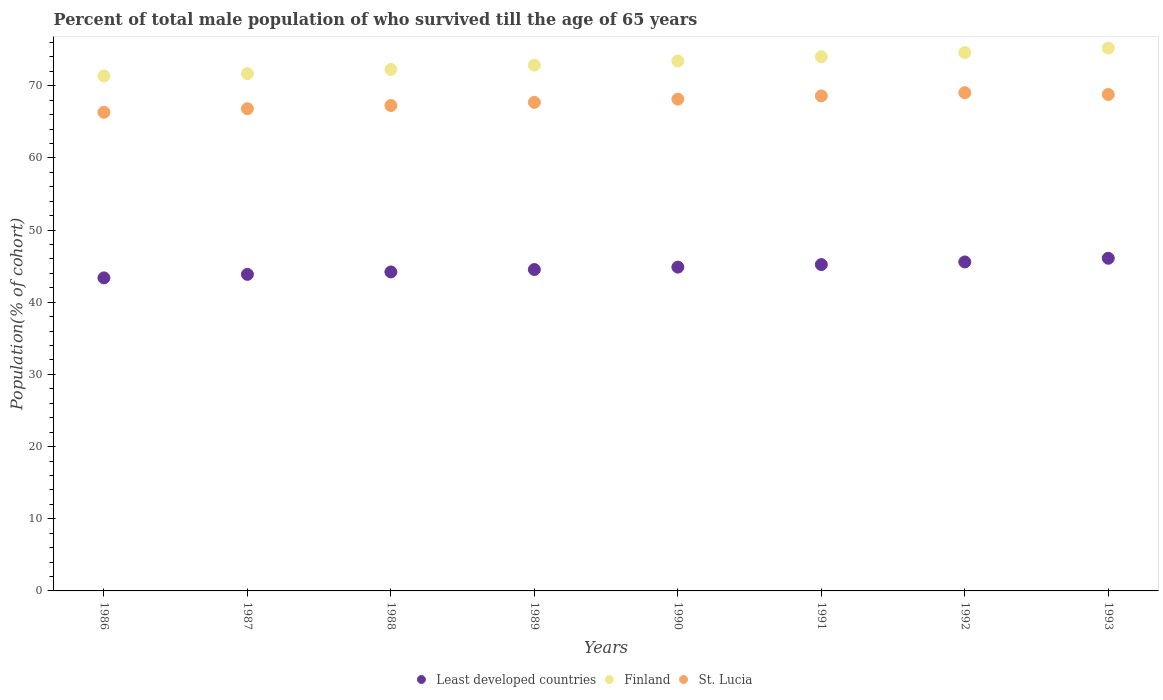What is the percentage of total male population who survived till the age of 65 years in Least developed countries in 1992?
Offer a very short reply. 45.58. Across all years, what is the maximum percentage of total male population who survived till the age of 65 years in Finland?
Your response must be concise. 75.22. Across all years, what is the minimum percentage of total male population who survived till the age of 65 years in Least developed countries?
Keep it short and to the point. 43.37. In which year was the percentage of total male population who survived till the age of 65 years in Finland minimum?
Your response must be concise. 1986. What is the total percentage of total male population who survived till the age of 65 years in Finland in the graph?
Provide a short and direct response. 585.42. What is the difference between the percentage of total male population who survived till the age of 65 years in Least developed countries in 1986 and that in 1993?
Ensure brevity in your answer.  -2.72. What is the difference between the percentage of total male population who survived till the age of 65 years in Least developed countries in 1988 and the percentage of total male population who survived till the age of 65 years in Finland in 1990?
Make the answer very short. -29.23. What is the average percentage of total male population who survived till the age of 65 years in Least developed countries per year?
Offer a very short reply. 44.72. In the year 1987, what is the difference between the percentage of total male population who survived till the age of 65 years in St. Lucia and percentage of total male population who survived till the age of 65 years in Least developed countries?
Provide a succinct answer. 22.95. In how many years, is the percentage of total male population who survived till the age of 65 years in Finland greater than 22 %?
Your response must be concise. 8. What is the ratio of the percentage of total male population who survived till the age of 65 years in St. Lucia in 1986 to that in 1989?
Your response must be concise. 0.98. Is the difference between the percentage of total male population who survived till the age of 65 years in St. Lucia in 1990 and 1993 greater than the difference between the percentage of total male population who survived till the age of 65 years in Least developed countries in 1990 and 1993?
Your answer should be very brief. Yes. What is the difference between the highest and the second highest percentage of total male population who survived till the age of 65 years in Least developed countries?
Offer a very short reply. 0.51. What is the difference between the highest and the lowest percentage of total male population who survived till the age of 65 years in St. Lucia?
Offer a terse response. 2.71. Does the percentage of total male population who survived till the age of 65 years in Finland monotonically increase over the years?
Provide a succinct answer. Yes. Is the percentage of total male population who survived till the age of 65 years in Least developed countries strictly greater than the percentage of total male population who survived till the age of 65 years in St. Lucia over the years?
Keep it short and to the point. No. Is the percentage of total male population who survived till the age of 65 years in Finland strictly less than the percentage of total male population who survived till the age of 65 years in Least developed countries over the years?
Provide a short and direct response. No. How many dotlines are there?
Provide a succinct answer. 3. Does the graph contain grids?
Make the answer very short. No. What is the title of the graph?
Offer a terse response. Percent of total male population of who survived till the age of 65 years. Does "Venezuela" appear as one of the legend labels in the graph?
Give a very brief answer. No. What is the label or title of the Y-axis?
Your response must be concise. Population(% of cohort). What is the Population(% of cohort) of Least developed countries in 1986?
Your response must be concise. 43.37. What is the Population(% of cohort) in Finland in 1986?
Your answer should be very brief. 71.36. What is the Population(% of cohort) in St. Lucia in 1986?
Ensure brevity in your answer.  66.32. What is the Population(% of cohort) in Least developed countries in 1987?
Make the answer very short. 43.86. What is the Population(% of cohort) of Finland in 1987?
Give a very brief answer. 71.68. What is the Population(% of cohort) in St. Lucia in 1987?
Offer a terse response. 66.81. What is the Population(% of cohort) in Least developed countries in 1988?
Provide a short and direct response. 44.2. What is the Population(% of cohort) in Finland in 1988?
Your answer should be compact. 72.26. What is the Population(% of cohort) of St. Lucia in 1988?
Ensure brevity in your answer.  67.26. What is the Population(% of cohort) of Least developed countries in 1989?
Offer a very short reply. 44.53. What is the Population(% of cohort) of Finland in 1989?
Ensure brevity in your answer.  72.85. What is the Population(% of cohort) in St. Lucia in 1989?
Ensure brevity in your answer.  67.7. What is the Population(% of cohort) in Least developed countries in 1990?
Ensure brevity in your answer.  44.87. What is the Population(% of cohort) of Finland in 1990?
Provide a short and direct response. 73.43. What is the Population(% of cohort) of St. Lucia in 1990?
Provide a short and direct response. 68.14. What is the Population(% of cohort) of Least developed countries in 1991?
Offer a very short reply. 45.22. What is the Population(% of cohort) in Finland in 1991?
Offer a very short reply. 74.02. What is the Population(% of cohort) in St. Lucia in 1991?
Your answer should be very brief. 68.59. What is the Population(% of cohort) of Least developed countries in 1992?
Keep it short and to the point. 45.58. What is the Population(% of cohort) in Finland in 1992?
Offer a very short reply. 74.61. What is the Population(% of cohort) in St. Lucia in 1992?
Give a very brief answer. 69.03. What is the Population(% of cohort) in Least developed countries in 1993?
Your answer should be very brief. 46.09. What is the Population(% of cohort) in Finland in 1993?
Ensure brevity in your answer.  75.22. What is the Population(% of cohort) of St. Lucia in 1993?
Provide a succinct answer. 68.79. Across all years, what is the maximum Population(% of cohort) of Least developed countries?
Give a very brief answer. 46.09. Across all years, what is the maximum Population(% of cohort) of Finland?
Give a very brief answer. 75.22. Across all years, what is the maximum Population(% of cohort) of St. Lucia?
Your answer should be compact. 69.03. Across all years, what is the minimum Population(% of cohort) of Least developed countries?
Your response must be concise. 43.37. Across all years, what is the minimum Population(% of cohort) in Finland?
Give a very brief answer. 71.36. Across all years, what is the minimum Population(% of cohort) in St. Lucia?
Ensure brevity in your answer.  66.32. What is the total Population(% of cohort) in Least developed countries in the graph?
Make the answer very short. 357.73. What is the total Population(% of cohort) of Finland in the graph?
Provide a succinct answer. 585.42. What is the total Population(% of cohort) of St. Lucia in the graph?
Make the answer very short. 542.64. What is the difference between the Population(% of cohort) in Least developed countries in 1986 and that in 1987?
Give a very brief answer. -0.49. What is the difference between the Population(% of cohort) of Finland in 1986 and that in 1987?
Ensure brevity in your answer.  -0.32. What is the difference between the Population(% of cohort) in St. Lucia in 1986 and that in 1987?
Give a very brief answer. -0.49. What is the difference between the Population(% of cohort) of Least developed countries in 1986 and that in 1988?
Your response must be concise. -0.83. What is the difference between the Population(% of cohort) of Finland in 1986 and that in 1988?
Your answer should be compact. -0.9. What is the difference between the Population(% of cohort) of St. Lucia in 1986 and that in 1988?
Ensure brevity in your answer.  -0.93. What is the difference between the Population(% of cohort) of Least developed countries in 1986 and that in 1989?
Ensure brevity in your answer.  -1.16. What is the difference between the Population(% of cohort) of Finland in 1986 and that in 1989?
Offer a terse response. -1.49. What is the difference between the Population(% of cohort) in St. Lucia in 1986 and that in 1989?
Make the answer very short. -1.38. What is the difference between the Population(% of cohort) of Least developed countries in 1986 and that in 1990?
Ensure brevity in your answer.  -1.49. What is the difference between the Population(% of cohort) of Finland in 1986 and that in 1990?
Give a very brief answer. -2.08. What is the difference between the Population(% of cohort) of St. Lucia in 1986 and that in 1990?
Keep it short and to the point. -1.82. What is the difference between the Population(% of cohort) in Least developed countries in 1986 and that in 1991?
Offer a terse response. -1.84. What is the difference between the Population(% of cohort) in Finland in 1986 and that in 1991?
Make the answer very short. -2.66. What is the difference between the Population(% of cohort) in St. Lucia in 1986 and that in 1991?
Provide a short and direct response. -2.27. What is the difference between the Population(% of cohort) in Least developed countries in 1986 and that in 1992?
Make the answer very short. -2.21. What is the difference between the Population(% of cohort) in Finland in 1986 and that in 1992?
Make the answer very short. -3.25. What is the difference between the Population(% of cohort) in St. Lucia in 1986 and that in 1992?
Keep it short and to the point. -2.71. What is the difference between the Population(% of cohort) in Least developed countries in 1986 and that in 1993?
Your response must be concise. -2.72. What is the difference between the Population(% of cohort) of Finland in 1986 and that in 1993?
Provide a short and direct response. -3.86. What is the difference between the Population(% of cohort) of St. Lucia in 1986 and that in 1993?
Ensure brevity in your answer.  -2.46. What is the difference between the Population(% of cohort) in Least developed countries in 1987 and that in 1988?
Your answer should be very brief. -0.34. What is the difference between the Population(% of cohort) in Finland in 1987 and that in 1988?
Provide a short and direct response. -0.59. What is the difference between the Population(% of cohort) in St. Lucia in 1987 and that in 1988?
Provide a succinct answer. -0.44. What is the difference between the Population(% of cohort) of Least developed countries in 1987 and that in 1989?
Your response must be concise. -0.67. What is the difference between the Population(% of cohort) in Finland in 1987 and that in 1989?
Provide a short and direct response. -1.17. What is the difference between the Population(% of cohort) in St. Lucia in 1987 and that in 1989?
Offer a very short reply. -0.89. What is the difference between the Population(% of cohort) in Least developed countries in 1987 and that in 1990?
Offer a terse response. -1. What is the difference between the Population(% of cohort) in Finland in 1987 and that in 1990?
Your answer should be compact. -1.76. What is the difference between the Population(% of cohort) of St. Lucia in 1987 and that in 1990?
Ensure brevity in your answer.  -1.33. What is the difference between the Population(% of cohort) of Least developed countries in 1987 and that in 1991?
Your response must be concise. -1.36. What is the difference between the Population(% of cohort) in Finland in 1987 and that in 1991?
Your answer should be very brief. -2.34. What is the difference between the Population(% of cohort) in St. Lucia in 1987 and that in 1991?
Make the answer very short. -1.78. What is the difference between the Population(% of cohort) of Least developed countries in 1987 and that in 1992?
Your answer should be very brief. -1.72. What is the difference between the Population(% of cohort) in Finland in 1987 and that in 1992?
Your answer should be very brief. -2.93. What is the difference between the Population(% of cohort) in St. Lucia in 1987 and that in 1992?
Ensure brevity in your answer.  -2.22. What is the difference between the Population(% of cohort) of Least developed countries in 1987 and that in 1993?
Your response must be concise. -2.23. What is the difference between the Population(% of cohort) of Finland in 1987 and that in 1993?
Make the answer very short. -3.54. What is the difference between the Population(% of cohort) in St. Lucia in 1987 and that in 1993?
Your answer should be compact. -1.97. What is the difference between the Population(% of cohort) of Least developed countries in 1988 and that in 1989?
Offer a terse response. -0.33. What is the difference between the Population(% of cohort) in Finland in 1988 and that in 1989?
Ensure brevity in your answer.  -0.59. What is the difference between the Population(% of cohort) in St. Lucia in 1988 and that in 1989?
Offer a very short reply. -0.44. What is the difference between the Population(% of cohort) of Least developed countries in 1988 and that in 1990?
Your answer should be very brief. -0.67. What is the difference between the Population(% of cohort) of Finland in 1988 and that in 1990?
Give a very brief answer. -1.17. What is the difference between the Population(% of cohort) of St. Lucia in 1988 and that in 1990?
Your answer should be compact. -0.89. What is the difference between the Population(% of cohort) of Least developed countries in 1988 and that in 1991?
Ensure brevity in your answer.  -1.02. What is the difference between the Population(% of cohort) in Finland in 1988 and that in 1991?
Give a very brief answer. -1.76. What is the difference between the Population(% of cohort) in St. Lucia in 1988 and that in 1991?
Make the answer very short. -1.33. What is the difference between the Population(% of cohort) of Least developed countries in 1988 and that in 1992?
Offer a very short reply. -1.38. What is the difference between the Population(% of cohort) of Finland in 1988 and that in 1992?
Your answer should be very brief. -2.34. What is the difference between the Population(% of cohort) in St. Lucia in 1988 and that in 1992?
Provide a succinct answer. -1.78. What is the difference between the Population(% of cohort) of Least developed countries in 1988 and that in 1993?
Ensure brevity in your answer.  -1.9. What is the difference between the Population(% of cohort) in Finland in 1988 and that in 1993?
Keep it short and to the point. -2.96. What is the difference between the Population(% of cohort) of St. Lucia in 1988 and that in 1993?
Ensure brevity in your answer.  -1.53. What is the difference between the Population(% of cohort) in Least developed countries in 1989 and that in 1990?
Your answer should be compact. -0.33. What is the difference between the Population(% of cohort) of Finland in 1989 and that in 1990?
Make the answer very short. -0.59. What is the difference between the Population(% of cohort) in St. Lucia in 1989 and that in 1990?
Make the answer very short. -0.44. What is the difference between the Population(% of cohort) of Least developed countries in 1989 and that in 1991?
Your answer should be compact. -0.69. What is the difference between the Population(% of cohort) of Finland in 1989 and that in 1991?
Your answer should be compact. -1.17. What is the difference between the Population(% of cohort) of St. Lucia in 1989 and that in 1991?
Give a very brief answer. -0.89. What is the difference between the Population(% of cohort) in Least developed countries in 1989 and that in 1992?
Offer a very short reply. -1.05. What is the difference between the Population(% of cohort) of Finland in 1989 and that in 1992?
Provide a succinct answer. -1.76. What is the difference between the Population(% of cohort) in St. Lucia in 1989 and that in 1992?
Give a very brief answer. -1.33. What is the difference between the Population(% of cohort) of Least developed countries in 1989 and that in 1993?
Your response must be concise. -1.56. What is the difference between the Population(% of cohort) of Finland in 1989 and that in 1993?
Offer a very short reply. -2.37. What is the difference between the Population(% of cohort) in St. Lucia in 1989 and that in 1993?
Your answer should be very brief. -1.09. What is the difference between the Population(% of cohort) of Least developed countries in 1990 and that in 1991?
Provide a short and direct response. -0.35. What is the difference between the Population(% of cohort) of Finland in 1990 and that in 1991?
Your answer should be compact. -0.59. What is the difference between the Population(% of cohort) of St. Lucia in 1990 and that in 1991?
Provide a succinct answer. -0.44. What is the difference between the Population(% of cohort) in Least developed countries in 1990 and that in 1992?
Offer a terse response. -0.72. What is the difference between the Population(% of cohort) of Finland in 1990 and that in 1992?
Offer a very short reply. -1.17. What is the difference between the Population(% of cohort) in St. Lucia in 1990 and that in 1992?
Make the answer very short. -0.89. What is the difference between the Population(% of cohort) in Least developed countries in 1990 and that in 1993?
Your answer should be compact. -1.23. What is the difference between the Population(% of cohort) of Finland in 1990 and that in 1993?
Your answer should be compact. -1.78. What is the difference between the Population(% of cohort) of St. Lucia in 1990 and that in 1993?
Offer a terse response. -0.64. What is the difference between the Population(% of cohort) in Least developed countries in 1991 and that in 1992?
Provide a succinct answer. -0.36. What is the difference between the Population(% of cohort) in Finland in 1991 and that in 1992?
Provide a succinct answer. -0.59. What is the difference between the Population(% of cohort) of St. Lucia in 1991 and that in 1992?
Give a very brief answer. -0.44. What is the difference between the Population(% of cohort) in Least developed countries in 1991 and that in 1993?
Your response must be concise. -0.88. What is the difference between the Population(% of cohort) in Finland in 1991 and that in 1993?
Keep it short and to the point. -1.2. What is the difference between the Population(% of cohort) of St. Lucia in 1991 and that in 1993?
Provide a short and direct response. -0.2. What is the difference between the Population(% of cohort) in Least developed countries in 1992 and that in 1993?
Ensure brevity in your answer.  -0.51. What is the difference between the Population(% of cohort) in Finland in 1992 and that in 1993?
Give a very brief answer. -0.61. What is the difference between the Population(% of cohort) in St. Lucia in 1992 and that in 1993?
Offer a terse response. 0.25. What is the difference between the Population(% of cohort) of Least developed countries in 1986 and the Population(% of cohort) of Finland in 1987?
Provide a short and direct response. -28.3. What is the difference between the Population(% of cohort) of Least developed countries in 1986 and the Population(% of cohort) of St. Lucia in 1987?
Your response must be concise. -23.44. What is the difference between the Population(% of cohort) in Finland in 1986 and the Population(% of cohort) in St. Lucia in 1987?
Make the answer very short. 4.55. What is the difference between the Population(% of cohort) of Least developed countries in 1986 and the Population(% of cohort) of Finland in 1988?
Keep it short and to the point. -28.89. What is the difference between the Population(% of cohort) of Least developed countries in 1986 and the Population(% of cohort) of St. Lucia in 1988?
Give a very brief answer. -23.88. What is the difference between the Population(% of cohort) of Finland in 1986 and the Population(% of cohort) of St. Lucia in 1988?
Your answer should be compact. 4.1. What is the difference between the Population(% of cohort) of Least developed countries in 1986 and the Population(% of cohort) of Finland in 1989?
Your answer should be very brief. -29.47. What is the difference between the Population(% of cohort) in Least developed countries in 1986 and the Population(% of cohort) in St. Lucia in 1989?
Provide a short and direct response. -24.33. What is the difference between the Population(% of cohort) of Finland in 1986 and the Population(% of cohort) of St. Lucia in 1989?
Your answer should be very brief. 3.66. What is the difference between the Population(% of cohort) in Least developed countries in 1986 and the Population(% of cohort) in Finland in 1990?
Provide a succinct answer. -30.06. What is the difference between the Population(% of cohort) of Least developed countries in 1986 and the Population(% of cohort) of St. Lucia in 1990?
Keep it short and to the point. -24.77. What is the difference between the Population(% of cohort) in Finland in 1986 and the Population(% of cohort) in St. Lucia in 1990?
Make the answer very short. 3.21. What is the difference between the Population(% of cohort) of Least developed countries in 1986 and the Population(% of cohort) of Finland in 1991?
Your answer should be compact. -30.65. What is the difference between the Population(% of cohort) in Least developed countries in 1986 and the Population(% of cohort) in St. Lucia in 1991?
Your answer should be very brief. -25.22. What is the difference between the Population(% of cohort) of Finland in 1986 and the Population(% of cohort) of St. Lucia in 1991?
Offer a terse response. 2.77. What is the difference between the Population(% of cohort) of Least developed countries in 1986 and the Population(% of cohort) of Finland in 1992?
Your answer should be very brief. -31.23. What is the difference between the Population(% of cohort) in Least developed countries in 1986 and the Population(% of cohort) in St. Lucia in 1992?
Make the answer very short. -25.66. What is the difference between the Population(% of cohort) in Finland in 1986 and the Population(% of cohort) in St. Lucia in 1992?
Provide a short and direct response. 2.32. What is the difference between the Population(% of cohort) in Least developed countries in 1986 and the Population(% of cohort) in Finland in 1993?
Keep it short and to the point. -31.84. What is the difference between the Population(% of cohort) of Least developed countries in 1986 and the Population(% of cohort) of St. Lucia in 1993?
Give a very brief answer. -25.41. What is the difference between the Population(% of cohort) of Finland in 1986 and the Population(% of cohort) of St. Lucia in 1993?
Make the answer very short. 2.57. What is the difference between the Population(% of cohort) in Least developed countries in 1987 and the Population(% of cohort) in Finland in 1988?
Give a very brief answer. -28.4. What is the difference between the Population(% of cohort) of Least developed countries in 1987 and the Population(% of cohort) of St. Lucia in 1988?
Provide a short and direct response. -23.39. What is the difference between the Population(% of cohort) in Finland in 1987 and the Population(% of cohort) in St. Lucia in 1988?
Your response must be concise. 4.42. What is the difference between the Population(% of cohort) in Least developed countries in 1987 and the Population(% of cohort) in Finland in 1989?
Ensure brevity in your answer.  -28.99. What is the difference between the Population(% of cohort) in Least developed countries in 1987 and the Population(% of cohort) in St. Lucia in 1989?
Make the answer very short. -23.84. What is the difference between the Population(% of cohort) in Finland in 1987 and the Population(% of cohort) in St. Lucia in 1989?
Make the answer very short. 3.98. What is the difference between the Population(% of cohort) of Least developed countries in 1987 and the Population(% of cohort) of Finland in 1990?
Offer a very short reply. -29.57. What is the difference between the Population(% of cohort) of Least developed countries in 1987 and the Population(% of cohort) of St. Lucia in 1990?
Offer a terse response. -24.28. What is the difference between the Population(% of cohort) of Finland in 1987 and the Population(% of cohort) of St. Lucia in 1990?
Provide a short and direct response. 3.53. What is the difference between the Population(% of cohort) of Least developed countries in 1987 and the Population(% of cohort) of Finland in 1991?
Make the answer very short. -30.16. What is the difference between the Population(% of cohort) of Least developed countries in 1987 and the Population(% of cohort) of St. Lucia in 1991?
Make the answer very short. -24.73. What is the difference between the Population(% of cohort) of Finland in 1987 and the Population(% of cohort) of St. Lucia in 1991?
Your answer should be very brief. 3.09. What is the difference between the Population(% of cohort) in Least developed countries in 1987 and the Population(% of cohort) in Finland in 1992?
Your response must be concise. -30.74. What is the difference between the Population(% of cohort) in Least developed countries in 1987 and the Population(% of cohort) in St. Lucia in 1992?
Offer a very short reply. -25.17. What is the difference between the Population(% of cohort) of Finland in 1987 and the Population(% of cohort) of St. Lucia in 1992?
Offer a terse response. 2.64. What is the difference between the Population(% of cohort) of Least developed countries in 1987 and the Population(% of cohort) of Finland in 1993?
Your response must be concise. -31.36. What is the difference between the Population(% of cohort) in Least developed countries in 1987 and the Population(% of cohort) in St. Lucia in 1993?
Ensure brevity in your answer.  -24.92. What is the difference between the Population(% of cohort) of Finland in 1987 and the Population(% of cohort) of St. Lucia in 1993?
Your answer should be very brief. 2.89. What is the difference between the Population(% of cohort) in Least developed countries in 1988 and the Population(% of cohort) in Finland in 1989?
Your answer should be compact. -28.65. What is the difference between the Population(% of cohort) in Least developed countries in 1988 and the Population(% of cohort) in St. Lucia in 1989?
Provide a short and direct response. -23.5. What is the difference between the Population(% of cohort) in Finland in 1988 and the Population(% of cohort) in St. Lucia in 1989?
Your answer should be compact. 4.56. What is the difference between the Population(% of cohort) of Least developed countries in 1988 and the Population(% of cohort) of Finland in 1990?
Keep it short and to the point. -29.23. What is the difference between the Population(% of cohort) of Least developed countries in 1988 and the Population(% of cohort) of St. Lucia in 1990?
Offer a terse response. -23.95. What is the difference between the Population(% of cohort) in Finland in 1988 and the Population(% of cohort) in St. Lucia in 1990?
Make the answer very short. 4.12. What is the difference between the Population(% of cohort) of Least developed countries in 1988 and the Population(% of cohort) of Finland in 1991?
Provide a short and direct response. -29.82. What is the difference between the Population(% of cohort) in Least developed countries in 1988 and the Population(% of cohort) in St. Lucia in 1991?
Your answer should be compact. -24.39. What is the difference between the Population(% of cohort) of Finland in 1988 and the Population(% of cohort) of St. Lucia in 1991?
Provide a short and direct response. 3.67. What is the difference between the Population(% of cohort) in Least developed countries in 1988 and the Population(% of cohort) in Finland in 1992?
Provide a succinct answer. -30.41. What is the difference between the Population(% of cohort) of Least developed countries in 1988 and the Population(% of cohort) of St. Lucia in 1992?
Offer a very short reply. -24.84. What is the difference between the Population(% of cohort) of Finland in 1988 and the Population(% of cohort) of St. Lucia in 1992?
Provide a short and direct response. 3.23. What is the difference between the Population(% of cohort) in Least developed countries in 1988 and the Population(% of cohort) in Finland in 1993?
Your response must be concise. -31.02. What is the difference between the Population(% of cohort) in Least developed countries in 1988 and the Population(% of cohort) in St. Lucia in 1993?
Offer a very short reply. -24.59. What is the difference between the Population(% of cohort) in Finland in 1988 and the Population(% of cohort) in St. Lucia in 1993?
Your response must be concise. 3.48. What is the difference between the Population(% of cohort) of Least developed countries in 1989 and the Population(% of cohort) of Finland in 1990?
Offer a terse response. -28.9. What is the difference between the Population(% of cohort) in Least developed countries in 1989 and the Population(% of cohort) in St. Lucia in 1990?
Your response must be concise. -23.61. What is the difference between the Population(% of cohort) of Finland in 1989 and the Population(% of cohort) of St. Lucia in 1990?
Offer a terse response. 4.7. What is the difference between the Population(% of cohort) in Least developed countries in 1989 and the Population(% of cohort) in Finland in 1991?
Provide a short and direct response. -29.49. What is the difference between the Population(% of cohort) in Least developed countries in 1989 and the Population(% of cohort) in St. Lucia in 1991?
Keep it short and to the point. -24.06. What is the difference between the Population(% of cohort) of Finland in 1989 and the Population(% of cohort) of St. Lucia in 1991?
Ensure brevity in your answer.  4.26. What is the difference between the Population(% of cohort) in Least developed countries in 1989 and the Population(% of cohort) in Finland in 1992?
Offer a terse response. -30.07. What is the difference between the Population(% of cohort) of Least developed countries in 1989 and the Population(% of cohort) of St. Lucia in 1992?
Keep it short and to the point. -24.5. What is the difference between the Population(% of cohort) of Finland in 1989 and the Population(% of cohort) of St. Lucia in 1992?
Provide a succinct answer. 3.81. What is the difference between the Population(% of cohort) in Least developed countries in 1989 and the Population(% of cohort) in Finland in 1993?
Your response must be concise. -30.69. What is the difference between the Population(% of cohort) in Least developed countries in 1989 and the Population(% of cohort) in St. Lucia in 1993?
Provide a succinct answer. -24.25. What is the difference between the Population(% of cohort) of Finland in 1989 and the Population(% of cohort) of St. Lucia in 1993?
Your answer should be very brief. 4.06. What is the difference between the Population(% of cohort) in Least developed countries in 1990 and the Population(% of cohort) in Finland in 1991?
Give a very brief answer. -29.15. What is the difference between the Population(% of cohort) in Least developed countries in 1990 and the Population(% of cohort) in St. Lucia in 1991?
Your response must be concise. -23.72. What is the difference between the Population(% of cohort) in Finland in 1990 and the Population(% of cohort) in St. Lucia in 1991?
Give a very brief answer. 4.84. What is the difference between the Population(% of cohort) of Least developed countries in 1990 and the Population(% of cohort) of Finland in 1992?
Your answer should be very brief. -29.74. What is the difference between the Population(% of cohort) in Least developed countries in 1990 and the Population(% of cohort) in St. Lucia in 1992?
Ensure brevity in your answer.  -24.17. What is the difference between the Population(% of cohort) of Finland in 1990 and the Population(% of cohort) of St. Lucia in 1992?
Your answer should be very brief. 4.4. What is the difference between the Population(% of cohort) in Least developed countries in 1990 and the Population(% of cohort) in Finland in 1993?
Your answer should be very brief. -30.35. What is the difference between the Population(% of cohort) in Least developed countries in 1990 and the Population(% of cohort) in St. Lucia in 1993?
Offer a very short reply. -23.92. What is the difference between the Population(% of cohort) of Finland in 1990 and the Population(% of cohort) of St. Lucia in 1993?
Your answer should be very brief. 4.65. What is the difference between the Population(% of cohort) in Least developed countries in 1991 and the Population(% of cohort) in Finland in 1992?
Offer a very short reply. -29.39. What is the difference between the Population(% of cohort) of Least developed countries in 1991 and the Population(% of cohort) of St. Lucia in 1992?
Give a very brief answer. -23.82. What is the difference between the Population(% of cohort) of Finland in 1991 and the Population(% of cohort) of St. Lucia in 1992?
Provide a short and direct response. 4.99. What is the difference between the Population(% of cohort) in Least developed countries in 1991 and the Population(% of cohort) in Finland in 1993?
Provide a short and direct response. -30. What is the difference between the Population(% of cohort) of Least developed countries in 1991 and the Population(% of cohort) of St. Lucia in 1993?
Offer a very short reply. -23.57. What is the difference between the Population(% of cohort) of Finland in 1991 and the Population(% of cohort) of St. Lucia in 1993?
Offer a terse response. 5.23. What is the difference between the Population(% of cohort) of Least developed countries in 1992 and the Population(% of cohort) of Finland in 1993?
Offer a terse response. -29.64. What is the difference between the Population(% of cohort) of Least developed countries in 1992 and the Population(% of cohort) of St. Lucia in 1993?
Your response must be concise. -23.2. What is the difference between the Population(% of cohort) of Finland in 1992 and the Population(% of cohort) of St. Lucia in 1993?
Your response must be concise. 5.82. What is the average Population(% of cohort) in Least developed countries per year?
Offer a very short reply. 44.72. What is the average Population(% of cohort) of Finland per year?
Keep it short and to the point. 73.18. What is the average Population(% of cohort) in St. Lucia per year?
Keep it short and to the point. 67.83. In the year 1986, what is the difference between the Population(% of cohort) in Least developed countries and Population(% of cohort) in Finland?
Offer a terse response. -27.98. In the year 1986, what is the difference between the Population(% of cohort) in Least developed countries and Population(% of cohort) in St. Lucia?
Keep it short and to the point. -22.95. In the year 1986, what is the difference between the Population(% of cohort) in Finland and Population(% of cohort) in St. Lucia?
Your answer should be compact. 5.03. In the year 1987, what is the difference between the Population(% of cohort) in Least developed countries and Population(% of cohort) in Finland?
Make the answer very short. -27.81. In the year 1987, what is the difference between the Population(% of cohort) of Least developed countries and Population(% of cohort) of St. Lucia?
Provide a succinct answer. -22.95. In the year 1987, what is the difference between the Population(% of cohort) in Finland and Population(% of cohort) in St. Lucia?
Provide a short and direct response. 4.87. In the year 1988, what is the difference between the Population(% of cohort) of Least developed countries and Population(% of cohort) of Finland?
Make the answer very short. -28.06. In the year 1988, what is the difference between the Population(% of cohort) of Least developed countries and Population(% of cohort) of St. Lucia?
Your response must be concise. -23.06. In the year 1988, what is the difference between the Population(% of cohort) in Finland and Population(% of cohort) in St. Lucia?
Offer a very short reply. 5.01. In the year 1989, what is the difference between the Population(% of cohort) of Least developed countries and Population(% of cohort) of Finland?
Offer a terse response. -28.32. In the year 1989, what is the difference between the Population(% of cohort) of Least developed countries and Population(% of cohort) of St. Lucia?
Your response must be concise. -23.17. In the year 1989, what is the difference between the Population(% of cohort) in Finland and Population(% of cohort) in St. Lucia?
Keep it short and to the point. 5.15. In the year 1990, what is the difference between the Population(% of cohort) in Least developed countries and Population(% of cohort) in Finland?
Your response must be concise. -28.57. In the year 1990, what is the difference between the Population(% of cohort) in Least developed countries and Population(% of cohort) in St. Lucia?
Give a very brief answer. -23.28. In the year 1990, what is the difference between the Population(% of cohort) in Finland and Population(% of cohort) in St. Lucia?
Your answer should be very brief. 5.29. In the year 1991, what is the difference between the Population(% of cohort) in Least developed countries and Population(% of cohort) in Finland?
Give a very brief answer. -28.8. In the year 1991, what is the difference between the Population(% of cohort) in Least developed countries and Population(% of cohort) in St. Lucia?
Your answer should be very brief. -23.37. In the year 1991, what is the difference between the Population(% of cohort) of Finland and Population(% of cohort) of St. Lucia?
Give a very brief answer. 5.43. In the year 1992, what is the difference between the Population(% of cohort) in Least developed countries and Population(% of cohort) in Finland?
Provide a short and direct response. -29.02. In the year 1992, what is the difference between the Population(% of cohort) in Least developed countries and Population(% of cohort) in St. Lucia?
Offer a very short reply. -23.45. In the year 1992, what is the difference between the Population(% of cohort) in Finland and Population(% of cohort) in St. Lucia?
Offer a very short reply. 5.57. In the year 1993, what is the difference between the Population(% of cohort) of Least developed countries and Population(% of cohort) of Finland?
Your response must be concise. -29.12. In the year 1993, what is the difference between the Population(% of cohort) of Least developed countries and Population(% of cohort) of St. Lucia?
Offer a terse response. -22.69. In the year 1993, what is the difference between the Population(% of cohort) in Finland and Population(% of cohort) in St. Lucia?
Offer a terse response. 6.43. What is the ratio of the Population(% of cohort) in Least developed countries in 1986 to that in 1987?
Offer a very short reply. 0.99. What is the ratio of the Population(% of cohort) of Least developed countries in 1986 to that in 1988?
Your answer should be very brief. 0.98. What is the ratio of the Population(% of cohort) in Finland in 1986 to that in 1988?
Give a very brief answer. 0.99. What is the ratio of the Population(% of cohort) in St. Lucia in 1986 to that in 1988?
Your answer should be compact. 0.99. What is the ratio of the Population(% of cohort) of Finland in 1986 to that in 1989?
Offer a terse response. 0.98. What is the ratio of the Population(% of cohort) in St. Lucia in 1986 to that in 1989?
Make the answer very short. 0.98. What is the ratio of the Population(% of cohort) of Least developed countries in 1986 to that in 1990?
Your response must be concise. 0.97. What is the ratio of the Population(% of cohort) of Finland in 1986 to that in 1990?
Make the answer very short. 0.97. What is the ratio of the Population(% of cohort) in St. Lucia in 1986 to that in 1990?
Provide a succinct answer. 0.97. What is the ratio of the Population(% of cohort) of Least developed countries in 1986 to that in 1991?
Your answer should be very brief. 0.96. What is the ratio of the Population(% of cohort) of Finland in 1986 to that in 1991?
Make the answer very short. 0.96. What is the ratio of the Population(% of cohort) of St. Lucia in 1986 to that in 1991?
Offer a terse response. 0.97. What is the ratio of the Population(% of cohort) in Least developed countries in 1986 to that in 1992?
Keep it short and to the point. 0.95. What is the ratio of the Population(% of cohort) of Finland in 1986 to that in 1992?
Your response must be concise. 0.96. What is the ratio of the Population(% of cohort) of St. Lucia in 1986 to that in 1992?
Make the answer very short. 0.96. What is the ratio of the Population(% of cohort) in Least developed countries in 1986 to that in 1993?
Make the answer very short. 0.94. What is the ratio of the Population(% of cohort) of Finland in 1986 to that in 1993?
Keep it short and to the point. 0.95. What is the ratio of the Population(% of cohort) in St. Lucia in 1986 to that in 1993?
Offer a very short reply. 0.96. What is the ratio of the Population(% of cohort) of Least developed countries in 1987 to that in 1988?
Your answer should be compact. 0.99. What is the ratio of the Population(% of cohort) in Finland in 1987 to that in 1988?
Your answer should be compact. 0.99. What is the ratio of the Population(% of cohort) in Least developed countries in 1987 to that in 1989?
Provide a succinct answer. 0.98. What is the ratio of the Population(% of cohort) in Finland in 1987 to that in 1989?
Offer a terse response. 0.98. What is the ratio of the Population(% of cohort) of St. Lucia in 1987 to that in 1989?
Provide a succinct answer. 0.99. What is the ratio of the Population(% of cohort) in Least developed countries in 1987 to that in 1990?
Make the answer very short. 0.98. What is the ratio of the Population(% of cohort) of Finland in 1987 to that in 1990?
Provide a succinct answer. 0.98. What is the ratio of the Population(% of cohort) in St. Lucia in 1987 to that in 1990?
Your answer should be very brief. 0.98. What is the ratio of the Population(% of cohort) in Least developed countries in 1987 to that in 1991?
Provide a succinct answer. 0.97. What is the ratio of the Population(% of cohort) of Finland in 1987 to that in 1991?
Your answer should be compact. 0.97. What is the ratio of the Population(% of cohort) in St. Lucia in 1987 to that in 1991?
Your answer should be compact. 0.97. What is the ratio of the Population(% of cohort) in Least developed countries in 1987 to that in 1992?
Ensure brevity in your answer.  0.96. What is the ratio of the Population(% of cohort) in Finland in 1987 to that in 1992?
Ensure brevity in your answer.  0.96. What is the ratio of the Population(% of cohort) in St. Lucia in 1987 to that in 1992?
Make the answer very short. 0.97. What is the ratio of the Population(% of cohort) of Least developed countries in 1987 to that in 1993?
Provide a succinct answer. 0.95. What is the ratio of the Population(% of cohort) in Finland in 1987 to that in 1993?
Offer a terse response. 0.95. What is the ratio of the Population(% of cohort) of St. Lucia in 1987 to that in 1993?
Give a very brief answer. 0.97. What is the ratio of the Population(% of cohort) of Least developed countries in 1988 to that in 1989?
Give a very brief answer. 0.99. What is the ratio of the Population(% of cohort) of St. Lucia in 1988 to that in 1989?
Ensure brevity in your answer.  0.99. What is the ratio of the Population(% of cohort) in Least developed countries in 1988 to that in 1990?
Make the answer very short. 0.99. What is the ratio of the Population(% of cohort) of St. Lucia in 1988 to that in 1990?
Offer a very short reply. 0.99. What is the ratio of the Population(% of cohort) of Least developed countries in 1988 to that in 1991?
Give a very brief answer. 0.98. What is the ratio of the Population(% of cohort) in Finland in 1988 to that in 1991?
Offer a terse response. 0.98. What is the ratio of the Population(% of cohort) in St. Lucia in 1988 to that in 1991?
Your response must be concise. 0.98. What is the ratio of the Population(% of cohort) in Least developed countries in 1988 to that in 1992?
Make the answer very short. 0.97. What is the ratio of the Population(% of cohort) of Finland in 1988 to that in 1992?
Your response must be concise. 0.97. What is the ratio of the Population(% of cohort) of St. Lucia in 1988 to that in 1992?
Offer a terse response. 0.97. What is the ratio of the Population(% of cohort) in Least developed countries in 1988 to that in 1993?
Offer a terse response. 0.96. What is the ratio of the Population(% of cohort) of Finland in 1988 to that in 1993?
Offer a very short reply. 0.96. What is the ratio of the Population(% of cohort) of St. Lucia in 1988 to that in 1993?
Keep it short and to the point. 0.98. What is the ratio of the Population(% of cohort) in Finland in 1989 to that in 1990?
Your answer should be compact. 0.99. What is the ratio of the Population(% of cohort) in St. Lucia in 1989 to that in 1990?
Provide a succinct answer. 0.99. What is the ratio of the Population(% of cohort) in Least developed countries in 1989 to that in 1991?
Your response must be concise. 0.98. What is the ratio of the Population(% of cohort) of Finland in 1989 to that in 1991?
Provide a short and direct response. 0.98. What is the ratio of the Population(% of cohort) of St. Lucia in 1989 to that in 1991?
Give a very brief answer. 0.99. What is the ratio of the Population(% of cohort) in Least developed countries in 1989 to that in 1992?
Give a very brief answer. 0.98. What is the ratio of the Population(% of cohort) in Finland in 1989 to that in 1992?
Give a very brief answer. 0.98. What is the ratio of the Population(% of cohort) in St. Lucia in 1989 to that in 1992?
Your response must be concise. 0.98. What is the ratio of the Population(% of cohort) of Least developed countries in 1989 to that in 1993?
Your answer should be compact. 0.97. What is the ratio of the Population(% of cohort) in Finland in 1989 to that in 1993?
Your answer should be very brief. 0.97. What is the ratio of the Population(% of cohort) in St. Lucia in 1989 to that in 1993?
Keep it short and to the point. 0.98. What is the ratio of the Population(% of cohort) of Finland in 1990 to that in 1991?
Your answer should be compact. 0.99. What is the ratio of the Population(% of cohort) of St. Lucia in 1990 to that in 1991?
Keep it short and to the point. 0.99. What is the ratio of the Population(% of cohort) in Least developed countries in 1990 to that in 1992?
Your answer should be very brief. 0.98. What is the ratio of the Population(% of cohort) of Finland in 1990 to that in 1992?
Give a very brief answer. 0.98. What is the ratio of the Population(% of cohort) in St. Lucia in 1990 to that in 1992?
Provide a short and direct response. 0.99. What is the ratio of the Population(% of cohort) of Least developed countries in 1990 to that in 1993?
Ensure brevity in your answer.  0.97. What is the ratio of the Population(% of cohort) of Finland in 1990 to that in 1993?
Make the answer very short. 0.98. What is the ratio of the Population(% of cohort) of Least developed countries in 1991 to that in 1992?
Make the answer very short. 0.99. What is the ratio of the Population(% of cohort) in Finland in 1991 to that in 1992?
Offer a very short reply. 0.99. What is the ratio of the Population(% of cohort) of St. Lucia in 1991 to that in 1992?
Make the answer very short. 0.99. What is the ratio of the Population(% of cohort) in Least developed countries in 1991 to that in 1993?
Ensure brevity in your answer.  0.98. What is the ratio of the Population(% of cohort) of Finland in 1991 to that in 1993?
Your answer should be very brief. 0.98. What is the ratio of the Population(% of cohort) of Least developed countries in 1992 to that in 1993?
Provide a succinct answer. 0.99. What is the ratio of the Population(% of cohort) of Finland in 1992 to that in 1993?
Provide a succinct answer. 0.99. What is the ratio of the Population(% of cohort) in St. Lucia in 1992 to that in 1993?
Give a very brief answer. 1. What is the difference between the highest and the second highest Population(% of cohort) in Least developed countries?
Your answer should be compact. 0.51. What is the difference between the highest and the second highest Population(% of cohort) in Finland?
Keep it short and to the point. 0.61. What is the difference between the highest and the second highest Population(% of cohort) in St. Lucia?
Provide a short and direct response. 0.25. What is the difference between the highest and the lowest Population(% of cohort) in Least developed countries?
Offer a very short reply. 2.72. What is the difference between the highest and the lowest Population(% of cohort) of Finland?
Offer a very short reply. 3.86. What is the difference between the highest and the lowest Population(% of cohort) in St. Lucia?
Your response must be concise. 2.71. 